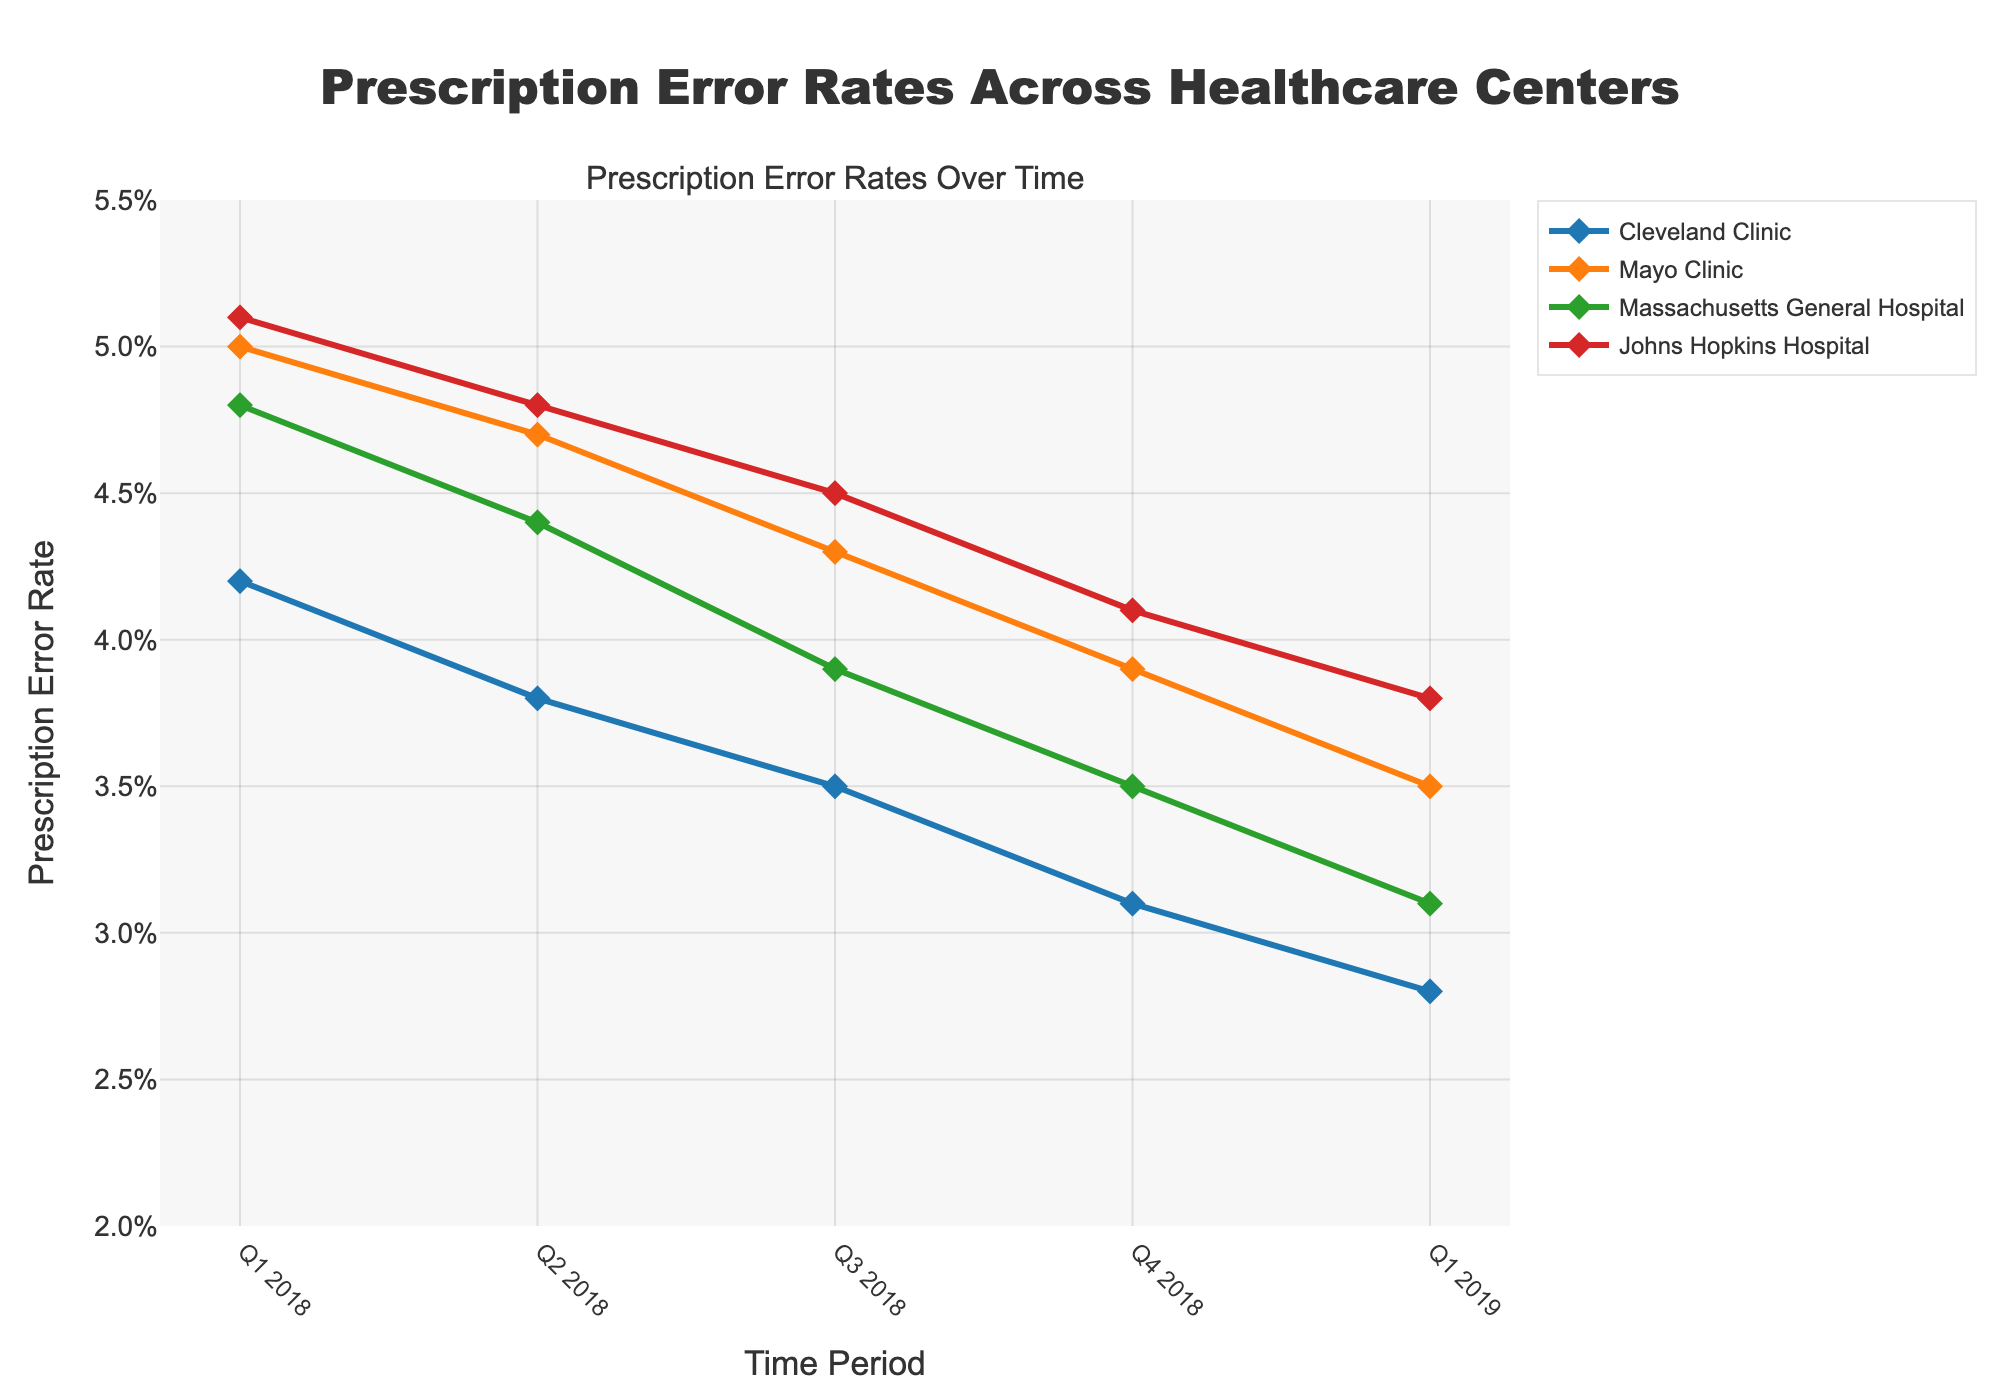Which healthcare center had the highest prescription error rate in Q1 2018? The highest prescription error rate is found by comparing the error rates for all the centers in Q1 2018. The centers have the following rates: Cleveland Clinic (4.2%), Mayo Clinic (5.0%), Massachusetts General Hospital (4.8%), and Johns Hopkins Hospital (5.1%).
Answer: Johns Hopkins Hospital What is the overall trend in prescription error rates for Cleveland Clinic from Q1 2018 to Q1 2019? By observing the line representing Cleveland Clinic, we can see a steady downward trend from Q1 2018 to Q1 2019, decreasing from 4.2% to 2.8%.
Answer: Downward trend How does the prescription error rate for Mayo Clinic in Q1 2019 compare to Q1 2018? First, identify the rates for Mayo Clinic in Q1 2018 (5.0%) and Q1 2019 (3.5%). Then, compare them to see that the error rate decreased by 1.5 percentage points.
Answer: Decreased Which healthcare center showed the smallest change in prescription error rates from Q1 2018 to Q1 2019? Calculate the difference in error rates from Q1 2018 to Q1 2019 for each center: Cleveland Clinic (4.2% - 2.8% = 1.4%), Mayo Clinic (5.0% - 3.5% = 1.5%), Massachusetts General Hospital (4.8% - 3.1% = 1.7%), Johns Hopkins Hospital (5.1% - 3.8% = 1.3%). The smallest change is for Johns Hopkins Hospital.
Answer: Johns Hopkins Hospital Between Q3 2018 and Q4 2018, which healthcare center had the greatest reduction in prescription error rates? Compare the differences between Q3 2018 and Q4 2018 for each center: Cleveland Clinic (3.5% - 3.1% = 0.4%), Mayo Clinic (4.3% - 3.9% = 0.4%), Massachusetts General Hospital (3.9% - 3.5% = 0.4%), Johns Hopkins Hospital (4.5% - 4.1% = 0.4%). All have the same reduction of 0.4%.
Answer: All centers (equal reduction) Which healthcare center had the lowest prescription error rate in Q1 2019? Compare the error rates for Q1 2019 for all centers: Cleveland Clinic (2.8%), Mayo Clinic (3.5%), Massachusetts General Hospital (3.1%), and Johns Hopkins Hospital (3.8%). The lowest rate is Cleveland Clinic.
Answer: Cleveland Clinic What is the average prescription error rate for Massachusetts General Hospital across all time periods shown? Calculate the mean of Massachusetts General Hospital's rates across Q1 2018 to Q1 2019: (4.8% + 4.4% + 3.9% + 3.5% + 3.1%) / 5. First, sum the percentages: 19.7%, then divide by 5: 19.7% / 5 = 3.94%.
Answer: 3.94% How did Johns Hopkins Hospital's prescription error rates in Q1 2019 compare to Mayo Clinic’s rates in Q4 2018? Compare the two rates: Johns Hopkins Hospital in Q1 2019 is 3.8%, and Mayo Clinic in Q4 2018 is 3.9%. Johns Hopkins' rate was slightly lower by 0.1 percentage point.
Answer: Slightly lower What overall trend can be observed across all healthcare centers regarding prescription error rates over the period from Q1 2018 to Q1 2019? Looking at the overall setup, all healthcare centers show a downward trend in prescription error rates from Q1 2018 to Q1 2019.
Answer: Downward trend 